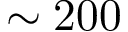<formula> <loc_0><loc_0><loc_500><loc_500>\sim 2 0 0</formula> 